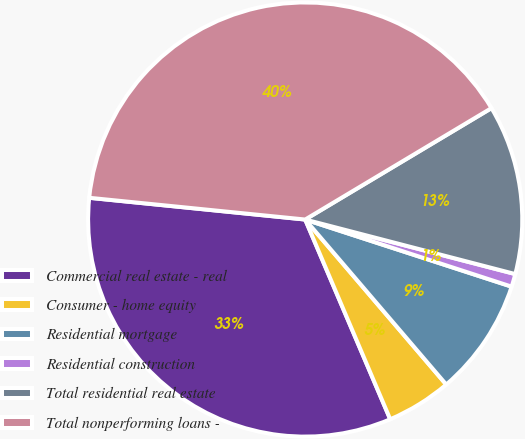<chart> <loc_0><loc_0><loc_500><loc_500><pie_chart><fcel>Commercial real estate - real<fcel>Consumer - home equity<fcel>Residential mortgage<fcel>Residential construction<fcel>Total residential real estate<fcel>Total nonperforming loans -<nl><fcel>33.0%<fcel>4.85%<fcel>8.74%<fcel>0.96%<fcel>12.62%<fcel>39.82%<nl></chart> 